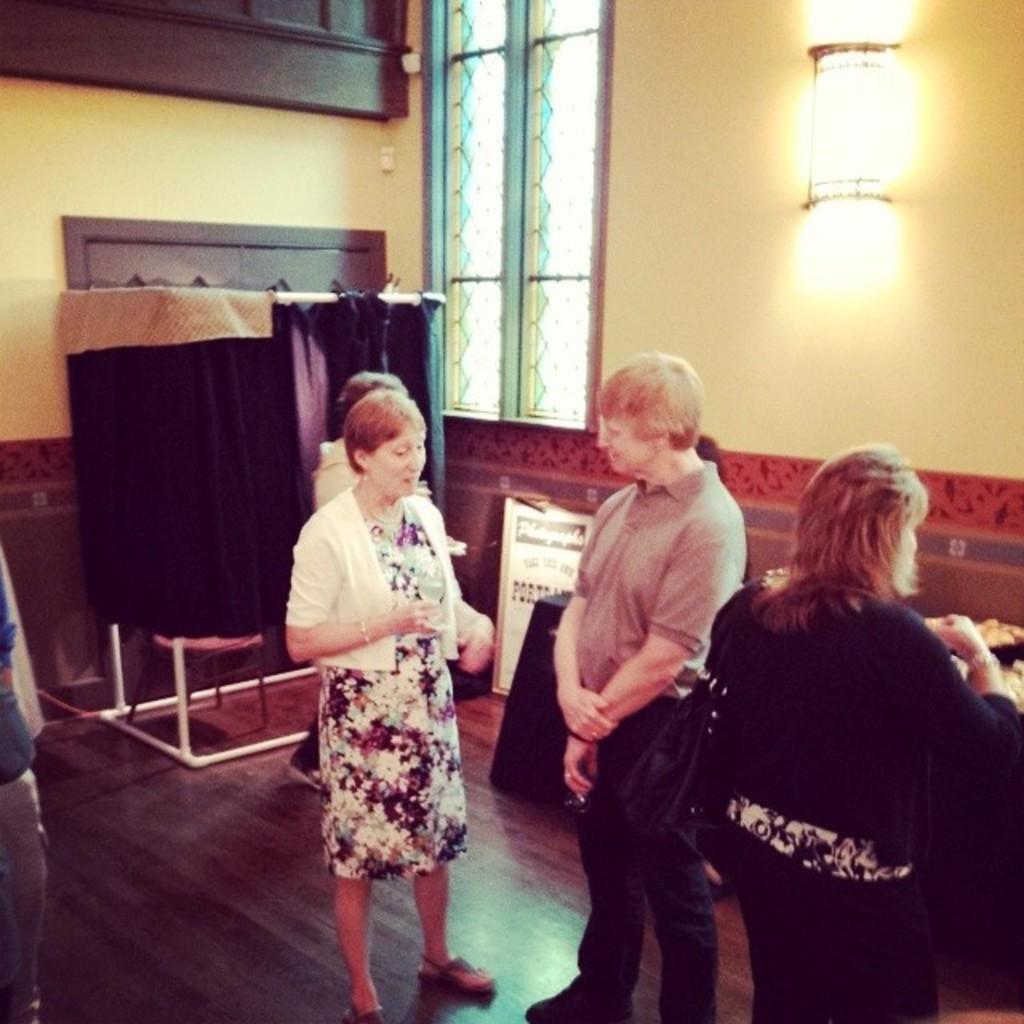Could you give a brief overview of what you see in this image? The picture is taken in a room. In the foreground of the picture there are people standing. On the left there is a person. In the center of the picture there are table, circular iron frame and cloth around it and other objects. At the top there are windows, light, wooden objects and wall. 